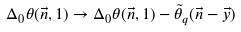<formula> <loc_0><loc_0><loc_500><loc_500>\Delta _ { 0 } \theta ( \vec { n } , 1 ) \to \Delta _ { 0 } \theta ( \vec { n } , 1 ) - \tilde { \theta } _ { q } ( \vec { n } - \vec { y } )</formula> 